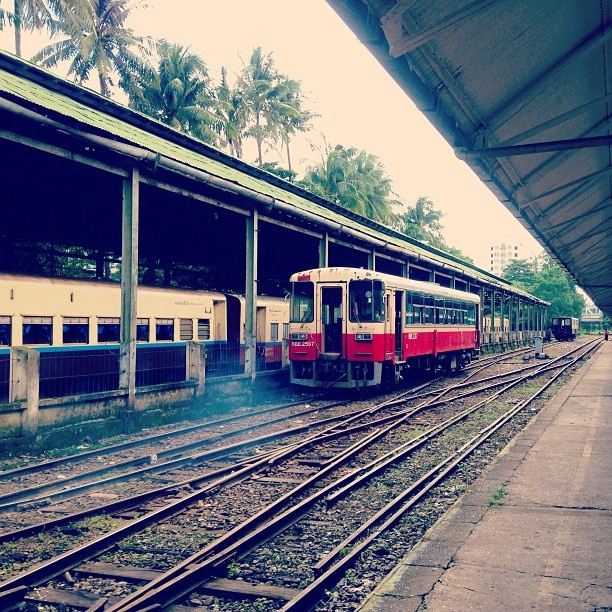Describe the objects in this image and their specific colors. I can see train in gray, navy, tan, and brown tones, train in gray, tan, navy, and darkgray tones, and train in gray, darkgray, tan, and black tones in this image. 